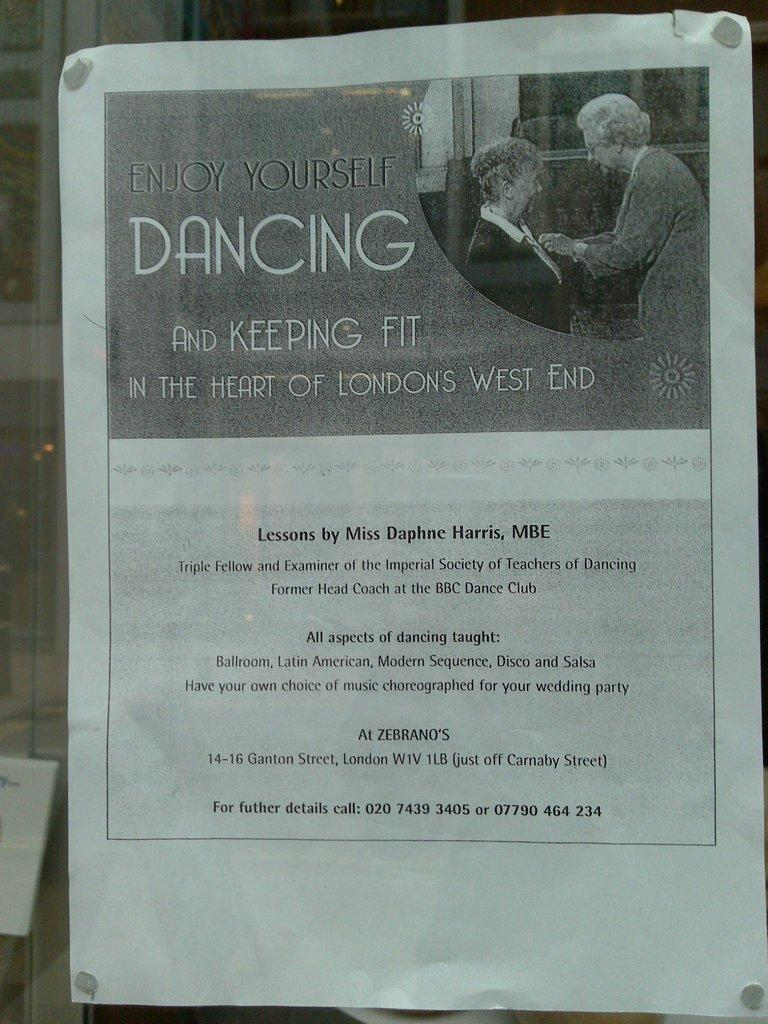What is the main subject in the image? There is a poster in the image. How many boys are swimming in the ocean depicted on the poster? There is no ocean or boys depicted on the poster; it only features a poster. 